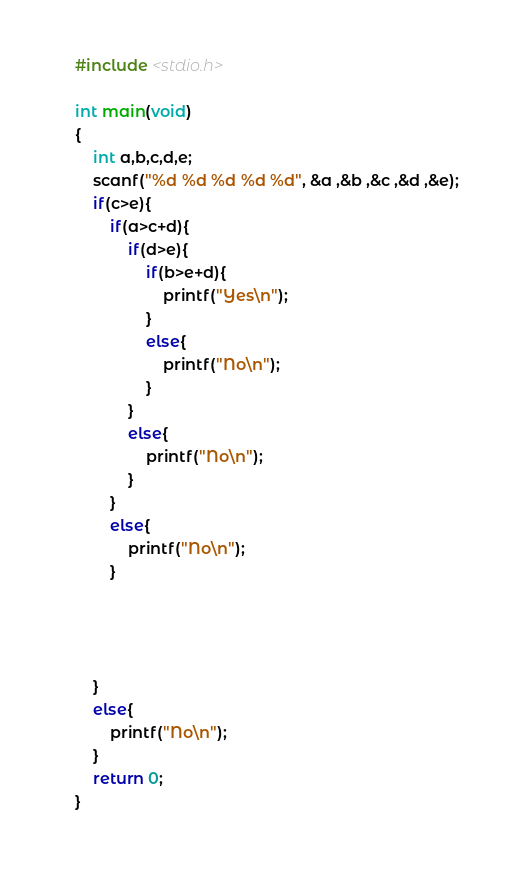Convert code to text. <code><loc_0><loc_0><loc_500><loc_500><_C_>#include <stdio.h>

int main(void)
{
    int a,b,c,d,e;
    scanf("%d %d %d %d %d", &a ,&b ,&c ,&d ,&e);
    if(c>e){
        if(a>c+d){
            if(d>e){
                if(b>e+d){
                    printf("Yes\n");
                }
                else{
                    printf("No\n");
                }
            }
            else{
                printf("No\n");
            }
        }
        else{
            printf("No\n");
        }

        
        
        
    }
    else{
        printf("No\n");
    }
    return 0;
}</code> 